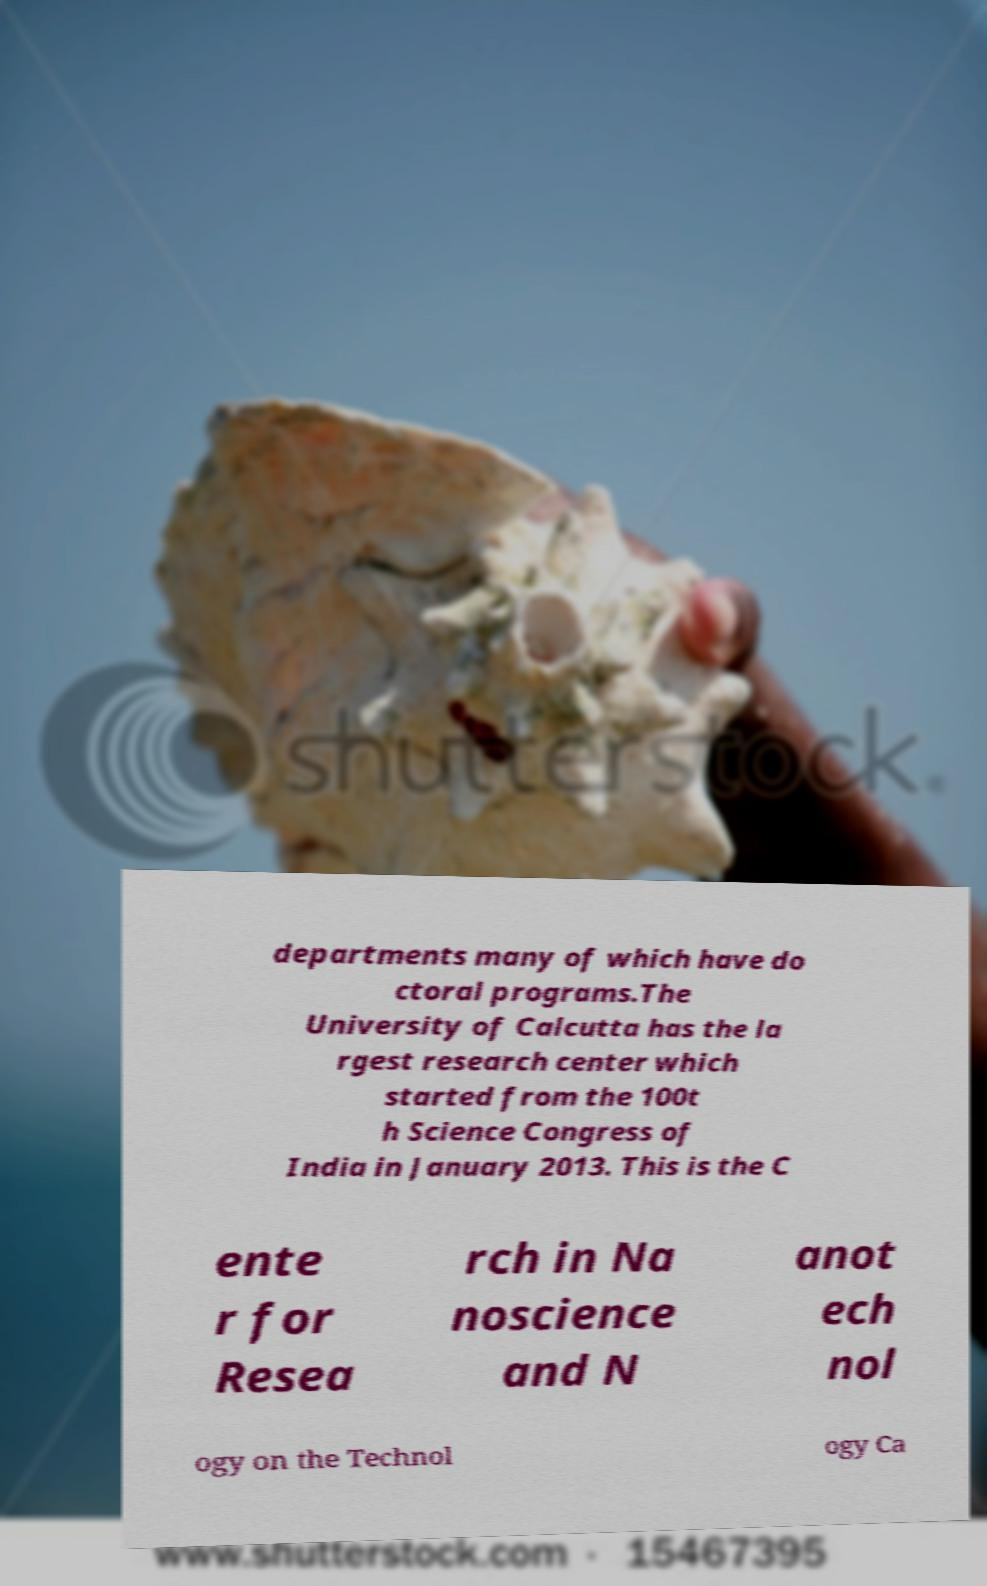There's text embedded in this image that I need extracted. Can you transcribe it verbatim? departments many of which have do ctoral programs.The University of Calcutta has the la rgest research center which started from the 100t h Science Congress of India in January 2013. This is the C ente r for Resea rch in Na noscience and N anot ech nol ogy on the Technol ogy Ca 